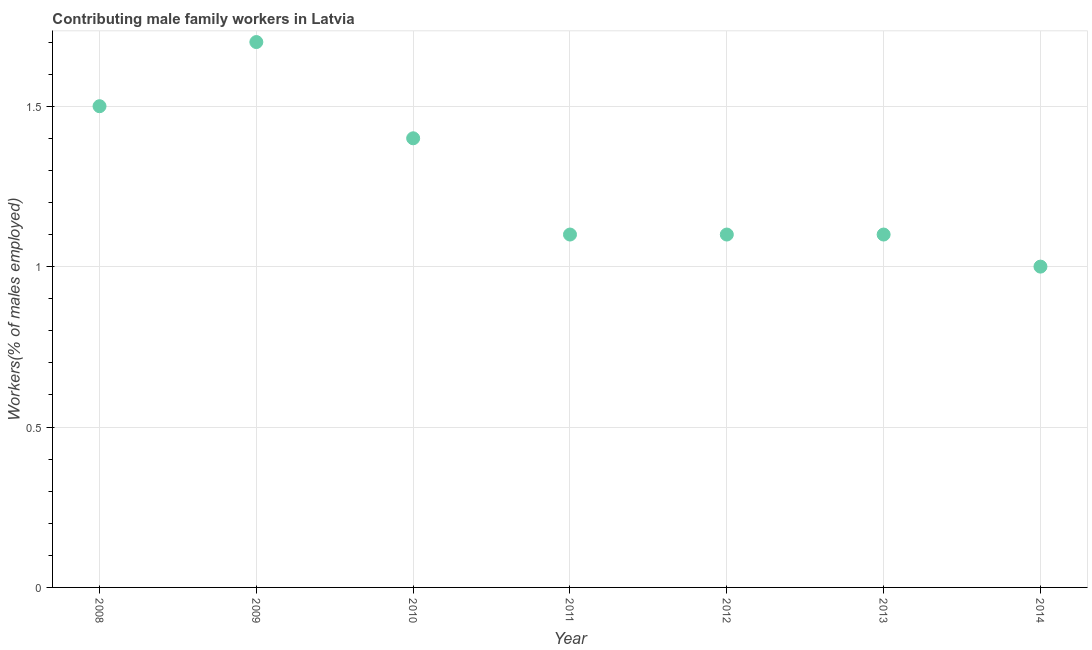What is the contributing male family workers in 2009?
Offer a terse response. 1.7. Across all years, what is the maximum contributing male family workers?
Make the answer very short. 1.7. In which year was the contributing male family workers maximum?
Your answer should be compact. 2009. In which year was the contributing male family workers minimum?
Give a very brief answer. 2014. What is the sum of the contributing male family workers?
Provide a short and direct response. 8.9. What is the difference between the contributing male family workers in 2009 and 2010?
Your answer should be very brief. 0.3. What is the average contributing male family workers per year?
Your answer should be compact. 1.27. What is the median contributing male family workers?
Keep it short and to the point. 1.1. In how many years, is the contributing male family workers greater than 0.6 %?
Ensure brevity in your answer.  7. Do a majority of the years between 2013 and 2010 (inclusive) have contributing male family workers greater than 0.6 %?
Provide a succinct answer. Yes. What is the ratio of the contributing male family workers in 2012 to that in 2014?
Offer a terse response. 1.1. Is the difference between the contributing male family workers in 2009 and 2014 greater than the difference between any two years?
Keep it short and to the point. Yes. What is the difference between the highest and the second highest contributing male family workers?
Offer a very short reply. 0.2. Is the sum of the contributing male family workers in 2008 and 2010 greater than the maximum contributing male family workers across all years?
Offer a very short reply. Yes. What is the difference between the highest and the lowest contributing male family workers?
Your answer should be compact. 0.7. How many years are there in the graph?
Make the answer very short. 7. What is the difference between two consecutive major ticks on the Y-axis?
Keep it short and to the point. 0.5. Does the graph contain grids?
Offer a terse response. Yes. What is the title of the graph?
Keep it short and to the point. Contributing male family workers in Latvia. What is the label or title of the Y-axis?
Your response must be concise. Workers(% of males employed). What is the Workers(% of males employed) in 2009?
Offer a terse response. 1.7. What is the Workers(% of males employed) in 2010?
Give a very brief answer. 1.4. What is the Workers(% of males employed) in 2011?
Keep it short and to the point. 1.1. What is the Workers(% of males employed) in 2012?
Your answer should be very brief. 1.1. What is the Workers(% of males employed) in 2013?
Your answer should be very brief. 1.1. What is the difference between the Workers(% of males employed) in 2008 and 2009?
Your answer should be very brief. -0.2. What is the difference between the Workers(% of males employed) in 2008 and 2011?
Make the answer very short. 0.4. What is the difference between the Workers(% of males employed) in 2008 and 2012?
Offer a very short reply. 0.4. What is the difference between the Workers(% of males employed) in 2009 and 2013?
Offer a terse response. 0.6. What is the difference between the Workers(% of males employed) in 2010 and 2012?
Provide a short and direct response. 0.3. What is the difference between the Workers(% of males employed) in 2010 and 2013?
Provide a short and direct response. 0.3. What is the difference between the Workers(% of males employed) in 2011 and 2012?
Give a very brief answer. 0. What is the difference between the Workers(% of males employed) in 2011 and 2013?
Ensure brevity in your answer.  0. What is the difference between the Workers(% of males employed) in 2012 and 2013?
Your response must be concise. 0. What is the difference between the Workers(% of males employed) in 2012 and 2014?
Provide a succinct answer. 0.1. What is the ratio of the Workers(% of males employed) in 2008 to that in 2009?
Give a very brief answer. 0.88. What is the ratio of the Workers(% of males employed) in 2008 to that in 2010?
Provide a succinct answer. 1.07. What is the ratio of the Workers(% of males employed) in 2008 to that in 2011?
Your answer should be very brief. 1.36. What is the ratio of the Workers(% of males employed) in 2008 to that in 2012?
Ensure brevity in your answer.  1.36. What is the ratio of the Workers(% of males employed) in 2008 to that in 2013?
Make the answer very short. 1.36. What is the ratio of the Workers(% of males employed) in 2009 to that in 2010?
Your answer should be compact. 1.21. What is the ratio of the Workers(% of males employed) in 2009 to that in 2011?
Your response must be concise. 1.54. What is the ratio of the Workers(% of males employed) in 2009 to that in 2012?
Keep it short and to the point. 1.54. What is the ratio of the Workers(% of males employed) in 2009 to that in 2013?
Keep it short and to the point. 1.54. What is the ratio of the Workers(% of males employed) in 2010 to that in 2011?
Provide a succinct answer. 1.27. What is the ratio of the Workers(% of males employed) in 2010 to that in 2012?
Give a very brief answer. 1.27. What is the ratio of the Workers(% of males employed) in 2010 to that in 2013?
Your answer should be very brief. 1.27. What is the ratio of the Workers(% of males employed) in 2010 to that in 2014?
Your response must be concise. 1.4. What is the ratio of the Workers(% of males employed) in 2011 to that in 2013?
Provide a short and direct response. 1. What is the ratio of the Workers(% of males employed) in 2011 to that in 2014?
Your answer should be very brief. 1.1. What is the ratio of the Workers(% of males employed) in 2012 to that in 2013?
Ensure brevity in your answer.  1. What is the ratio of the Workers(% of males employed) in 2012 to that in 2014?
Give a very brief answer. 1.1. What is the ratio of the Workers(% of males employed) in 2013 to that in 2014?
Provide a succinct answer. 1.1. 